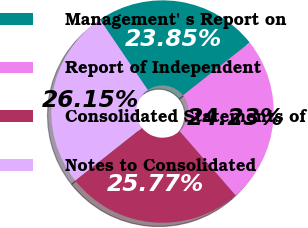Convert chart. <chart><loc_0><loc_0><loc_500><loc_500><pie_chart><fcel>Management' s Report on<fcel>Report of Independent<fcel>Consolidated Statements of<fcel>Notes to Consolidated<nl><fcel>23.85%<fcel>24.23%<fcel>25.77%<fcel>26.15%<nl></chart> 